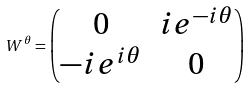<formula> <loc_0><loc_0><loc_500><loc_500>W ^ { \theta } = \begin{pmatrix} 0 & i e ^ { - i \theta } \\ - i e ^ { i \theta } & 0 \end{pmatrix}</formula> 